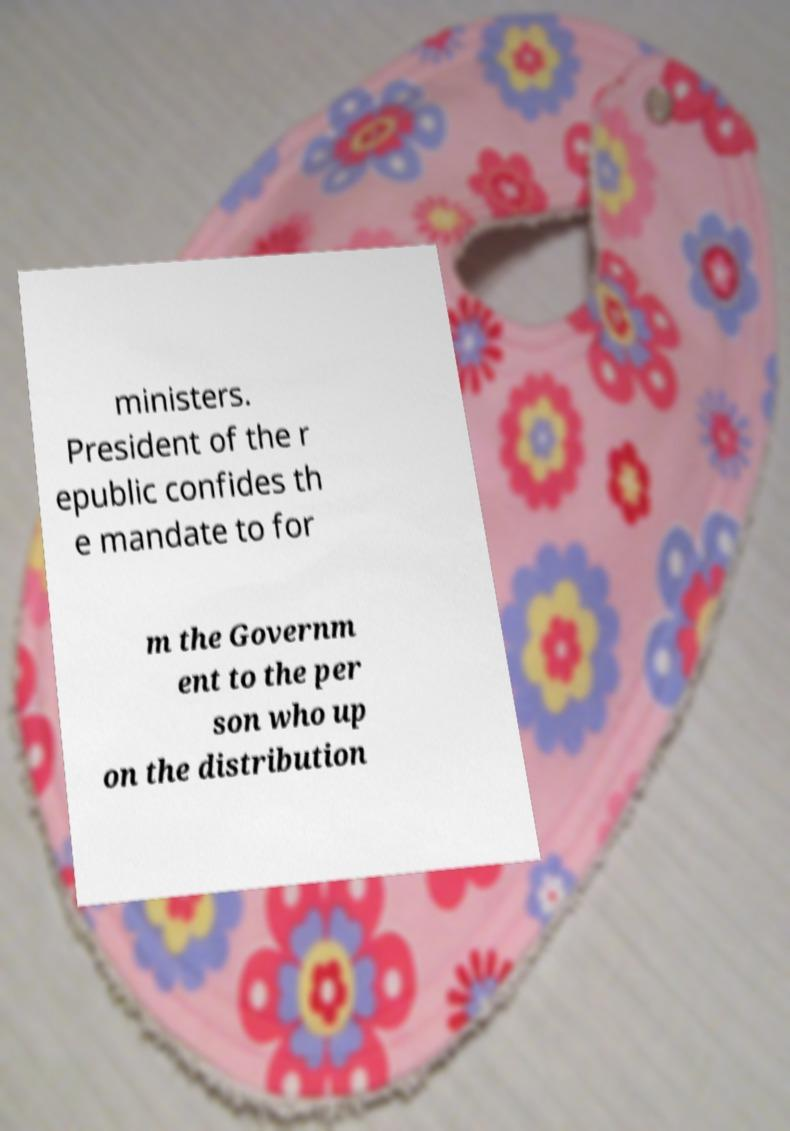What messages or text are displayed in this image? I need them in a readable, typed format. ministers. President of the r epublic confides th e mandate to for m the Governm ent to the per son who up on the distribution 